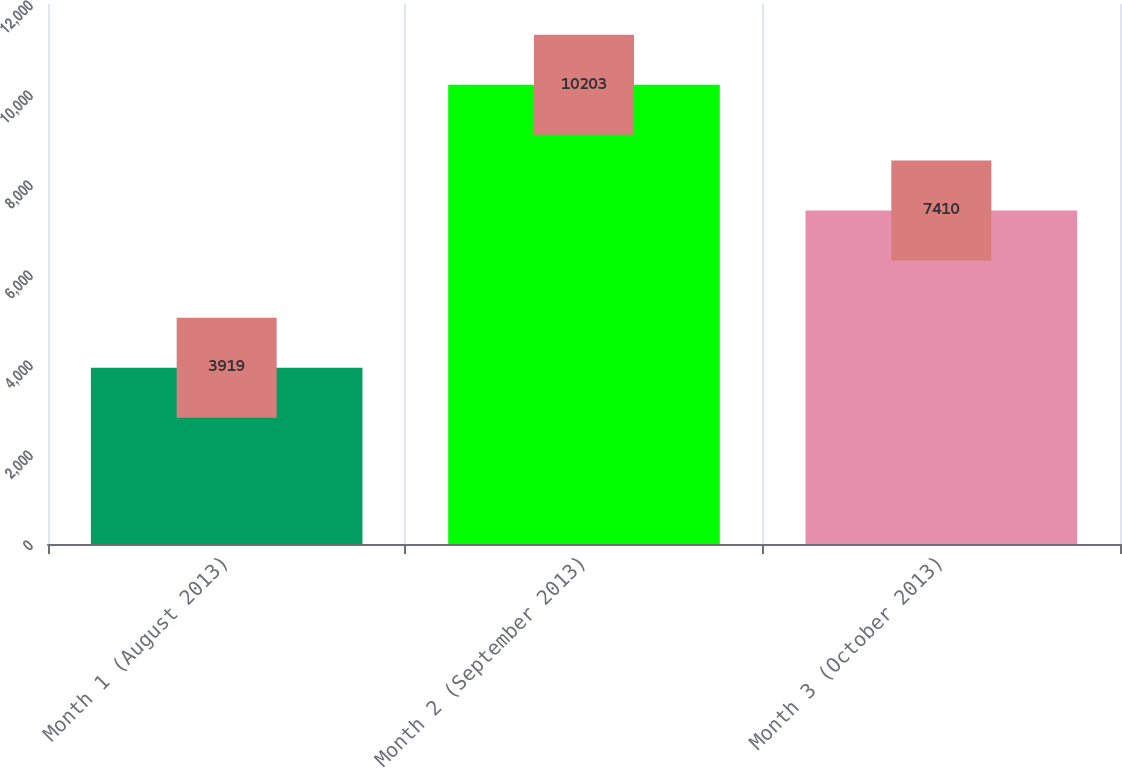Convert chart to OTSL. <chart><loc_0><loc_0><loc_500><loc_500><bar_chart><fcel>Month 1 (August 2013)<fcel>Month 2 (September 2013)<fcel>Month 3 (October 2013)<nl><fcel>3919<fcel>10203<fcel>7410<nl></chart> 